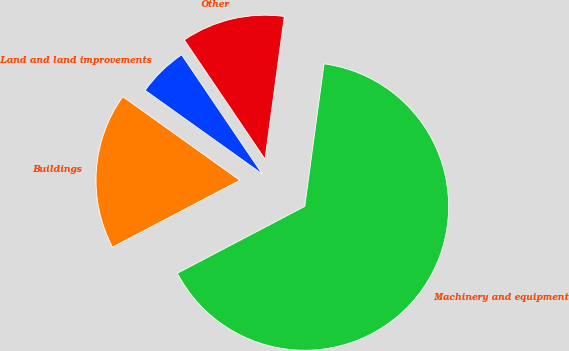<chart> <loc_0><loc_0><loc_500><loc_500><pie_chart><fcel>Land and land improvements<fcel>Buildings<fcel>Machinery and equipment<fcel>Other<nl><fcel>5.66%<fcel>17.56%<fcel>65.17%<fcel>11.61%<nl></chart> 